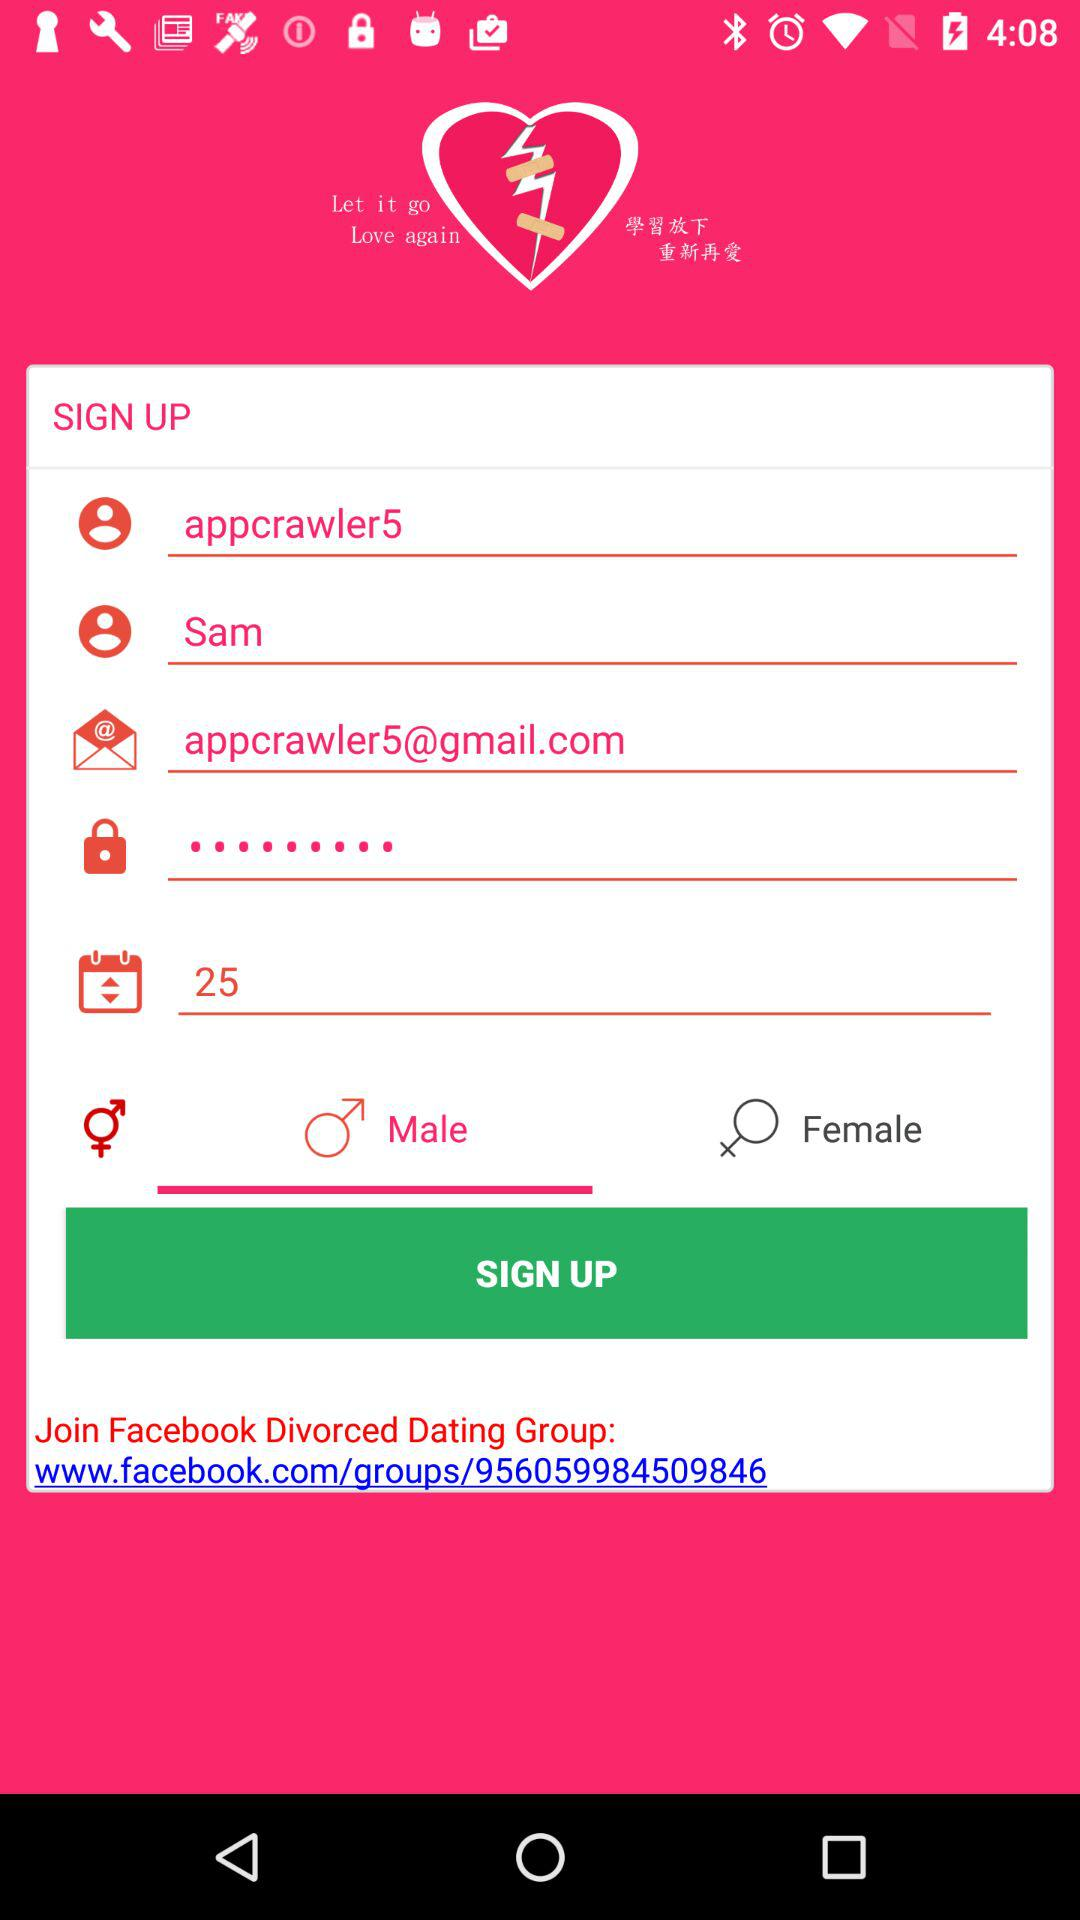Which gender is selected? The selected gender is "Male". 